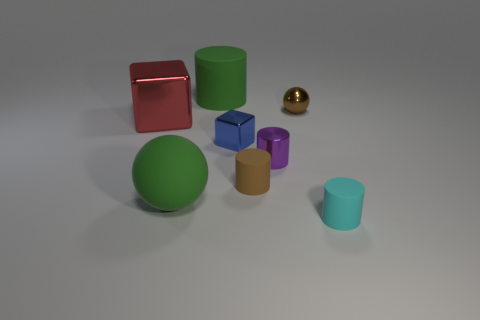How big is the green rubber thing that is in front of the small rubber object behind the ball in front of the brown metallic thing?
Offer a terse response. Large. What color is the tiny matte object in front of the big green rubber sphere?
Offer a very short reply. Cyan. Is the number of small metallic things that are in front of the small blue block greater than the number of brown metal spheres?
Your answer should be compact. No. There is a rubber thing that is on the right side of the brown rubber object; is it the same shape as the purple object?
Your response must be concise. Yes. How many yellow objects are either metal balls or large spheres?
Your response must be concise. 0. Are there more large rubber cylinders than small purple blocks?
Your answer should be compact. Yes. There is a metal sphere that is the same size as the blue cube; what is its color?
Your response must be concise. Brown. What number of spheres are either tiny brown metal objects or green rubber objects?
Your answer should be very brief. 2. There is a tiny blue metal thing; is its shape the same as the small matte thing that is left of the tiny cyan rubber cylinder?
Provide a succinct answer. No. What number of blue shiny blocks have the same size as the green matte ball?
Offer a very short reply. 0. 